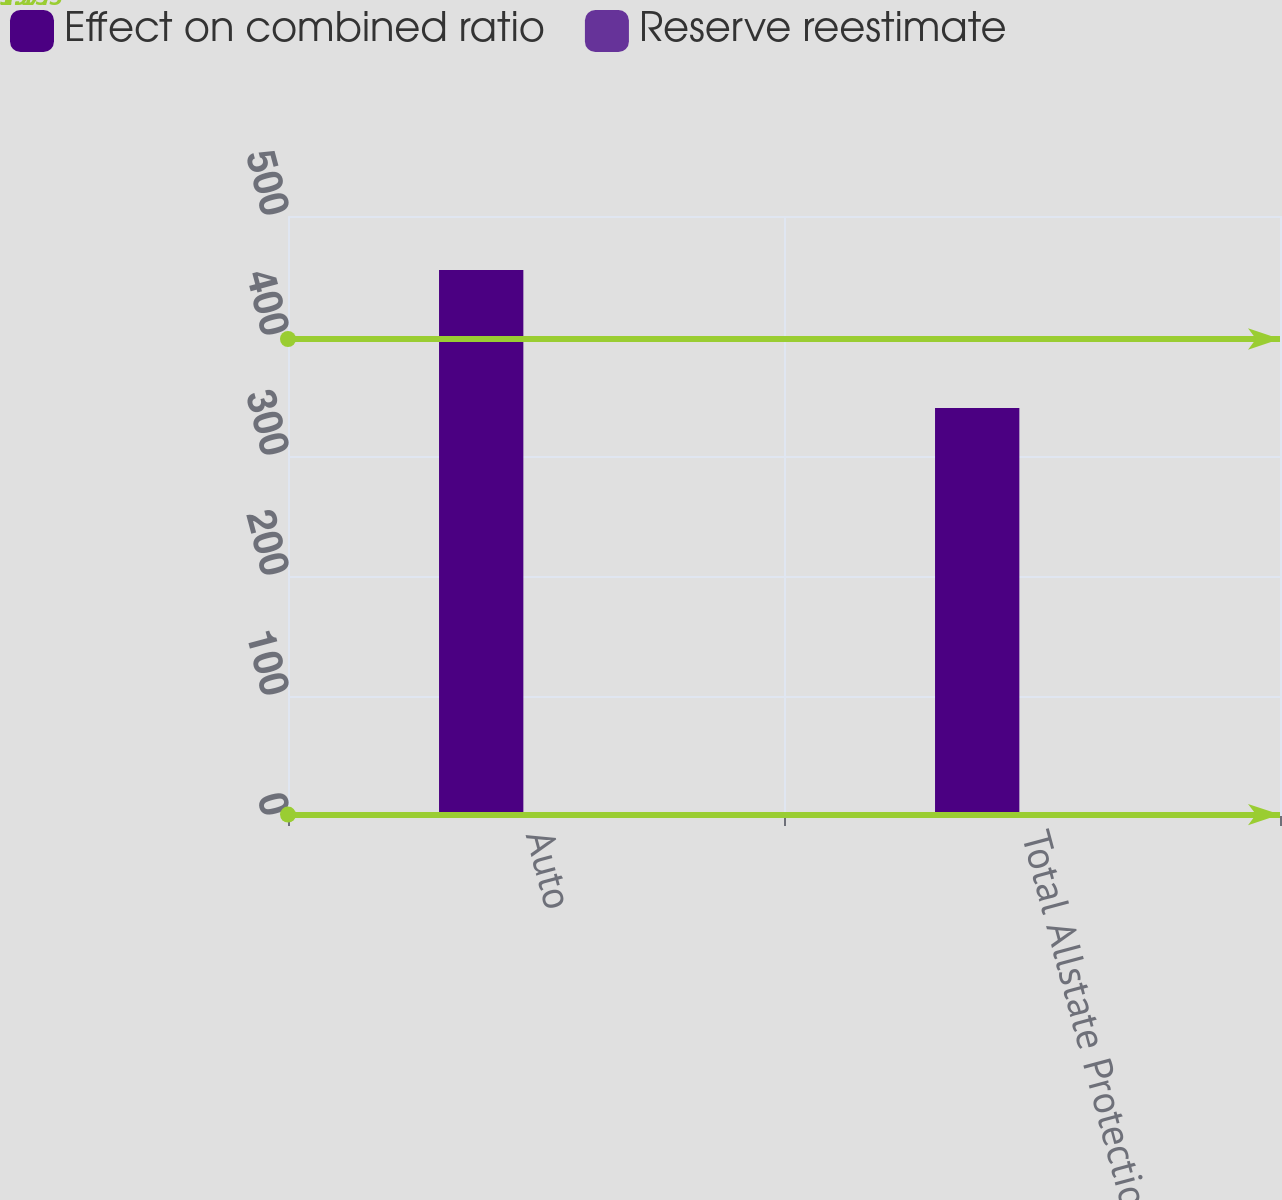Convert chart to OTSL. <chart><loc_0><loc_0><loc_500><loc_500><stacked_bar_chart><ecel><fcel>Auto<fcel>Total Allstate Protection<nl><fcel>Effect on combined ratio<fcel>455<fcel>340<nl><fcel>Reserve reestimate<fcel>1.3<fcel>1<nl></chart> 